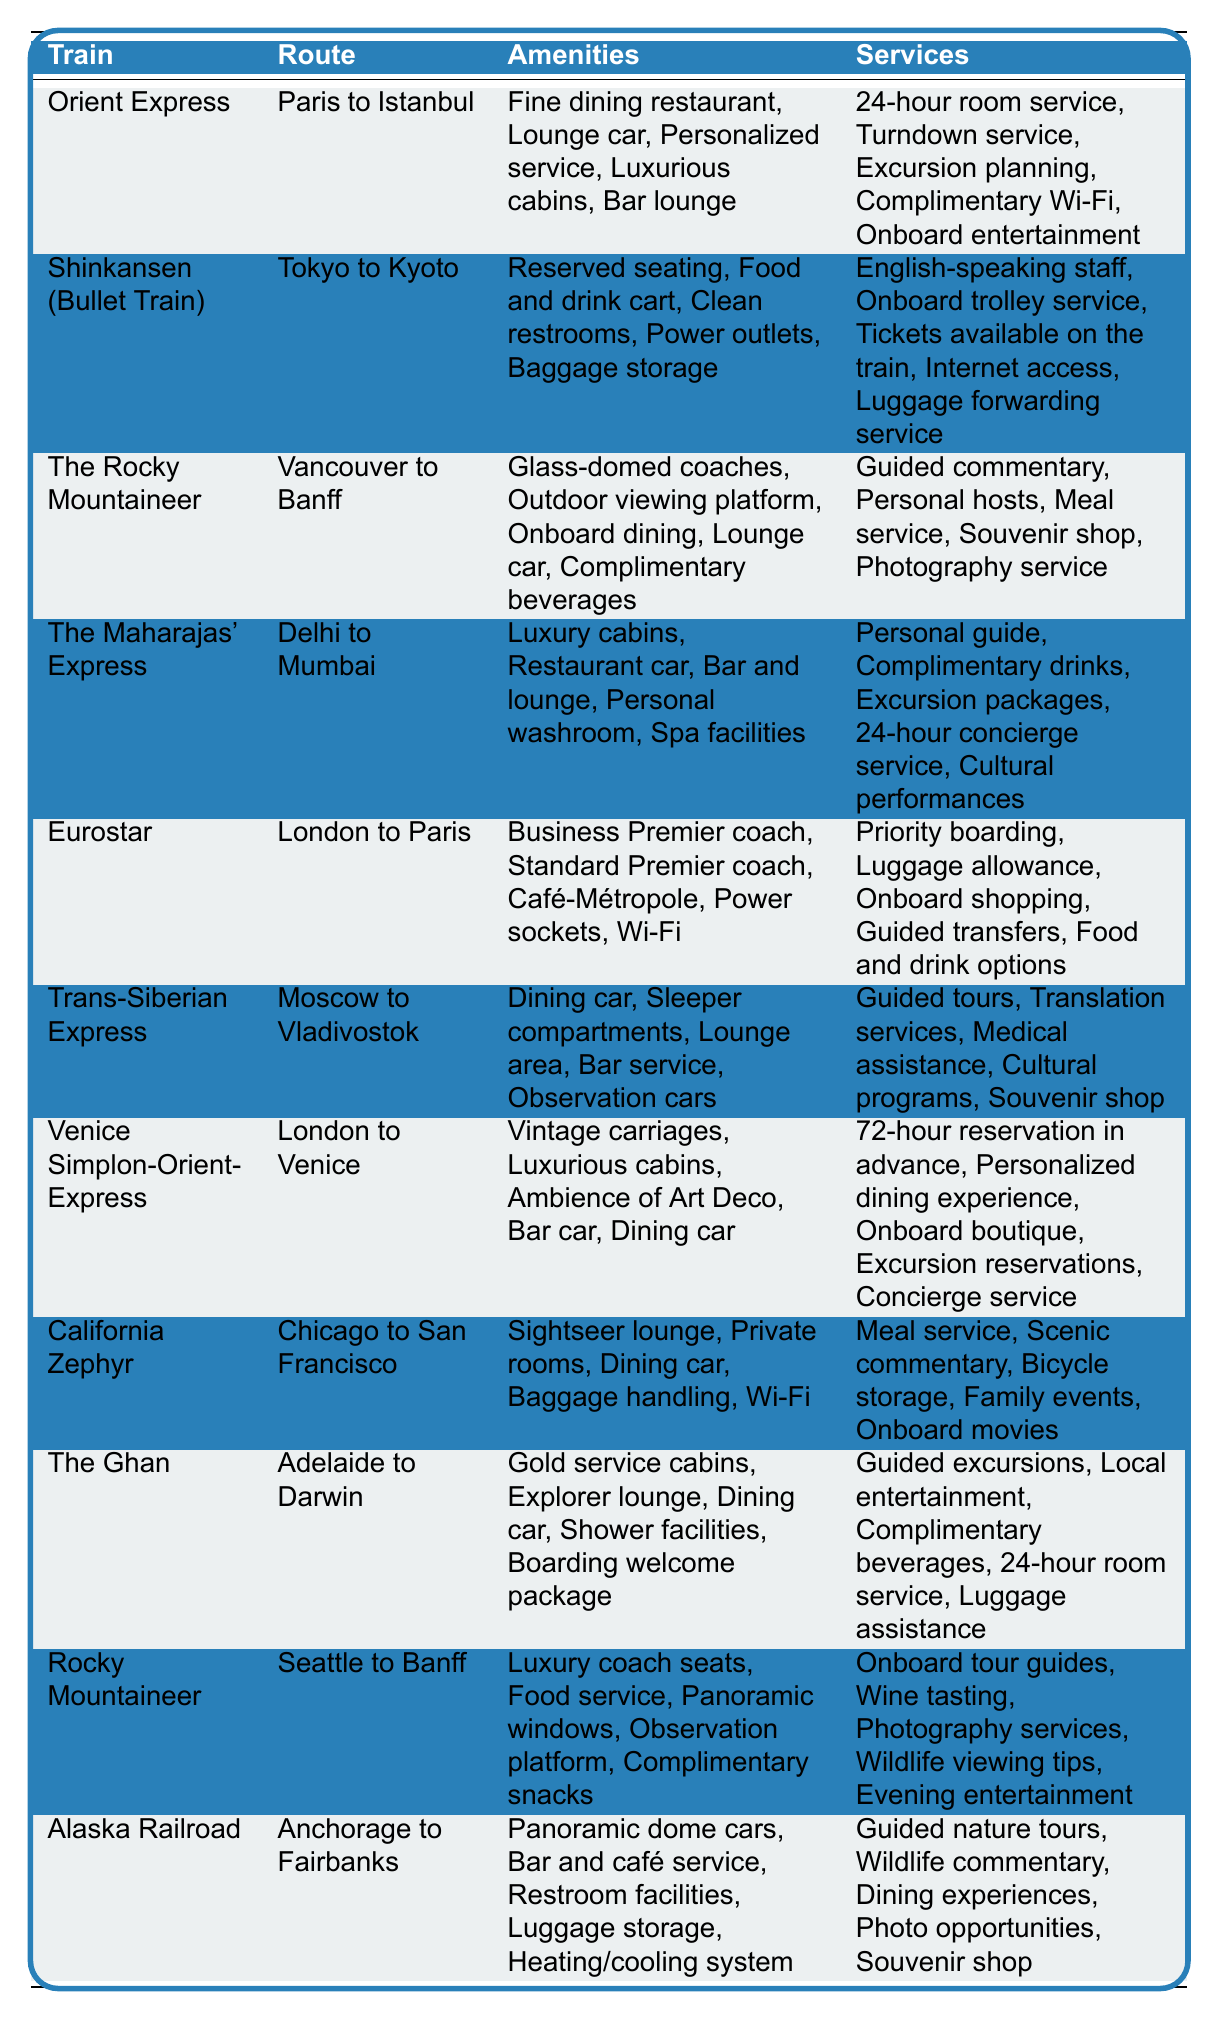What amenities does the Orient Express offer? The table lists the amenities for the Orient Express as: Fine dining restaurant, Lounge car, Personalized service, Luxurious cabins, and Bar lounge.
Answer: Fine dining restaurant, Lounge car, Personalized service, Luxurious cabins, Bar lounge Which train provides a spa facility? The Maharajas' Express is the only train listed in the table that provides spa facilities as one of its amenities.
Answer: The Maharajas' Express Does the Trans-Siberian Express offer guided tours? Yes, the Trans-Siberian Express includes guided tours as one of its services, confirming that such a service is available.
Answer: Yes How many trains have onboard dining options? The trains that offer onboard dining are: The Rocky Mountaineer, The Maharajas' Express, California Zephyr, and Rocky Mountaineer (Seattle to Banff), totaling four trains with such options.
Answer: Four trains What is the unique feature of the Rocky Mountaineer? The Rocky Mountaineer is distinguished by the feature of glass-domed coaches, allowing passengers to enjoy panoramic views of the scenery.
Answer: Glass-domed coaches Which trains provide complimentary beverages? The trains that offer complimentary beverages are The Rocky Mountaineer, The Ghan, and The Maharajas' Express. Hence, three trains provide this service.
Answer: Three trains Which train has the longest route? The Trans-Siberian Express has the longest route specified in the table, traveling from Moscow to Vladivostok over a significant distance compared to the other routes listed.
Answer: Trans-Siberian Express How does the service of meals on the Ghan compare to Eurostar? The Ghan includes meal service in its offerings while Eurostar provides food and drink options, indicating that both trains have culinary services but in different forms.
Answer: Both offer food options Which route offers a lounge car as an amenity? The routes that feature a lounge car as an amenity are on the Orient Express, The Rocky Mountaineer, and The Ghan, as indicated in the table.
Answer: Orient Express, The Rocky Mountaineer, The Ghan What kind of seating does the Shinkansen provide? The Shinkansen provides reserved seating and power outlets among its amenities, ensuring comfort and convenience for travelers.
Answer: Reserved seating and power outlets Are there any trains that enable luggage forwarding services? Yes, the Shinkansen provides a luggage forwarding service as part of its offerings, confirming the availability of this convenience.
Answer: Yes Which train offers personalized dining experiences? The Venice Simplon-Orient-Express is the train that offers personalized dining experiences, making it a unique feature of its service.
Answer: Venice Simplon-Orient-Express How many trains have a bar and lounge facility? The trains with a bar and lounge facility include The Maharajas' Express, Rocky Mountaineer, and the Orient Express, totaling three trains.
Answer: Three trains What services are provided by the Alaska Railroad? The Alaska Railroad provides guided nature tours, wildlife commentary, dining experiences, photo opportunities, and a souvenir shop, confirming a diverse range of services.
Answer: Guided nature tours, wildlife commentary, dining experiences, photo opportunities, souvenir shop Is internet access available on the California Zephyr? Yes, the California Zephyr provides Wi-Fi as part of its amenities, ensuring internet access for passengers.
Answer: Yes What is the distinct feature of the Venice Simplon-Orient-Express? The Venice Simplon-Orient-Express is characterized by its vintage carriages and the ambiance of Art Deco, providing a unique travel experience.
Answer: Vintage carriages and Art Deco ambiance 